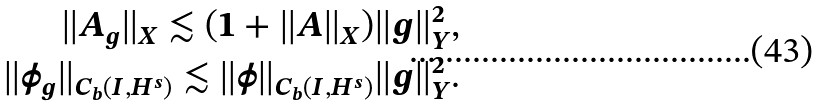<formula> <loc_0><loc_0><loc_500><loc_500>\| A _ { g } \| _ { X } \lesssim ( 1 + \| A \| _ { X } ) \| g \| ^ { 2 } _ { Y } , \\ \| \phi _ { g } \| _ { C _ { b } ( I , H ^ { s } ) } \lesssim \| \phi \| _ { C _ { b } ( I , H ^ { s } ) } \| g \| ^ { 2 } _ { Y } .</formula> 